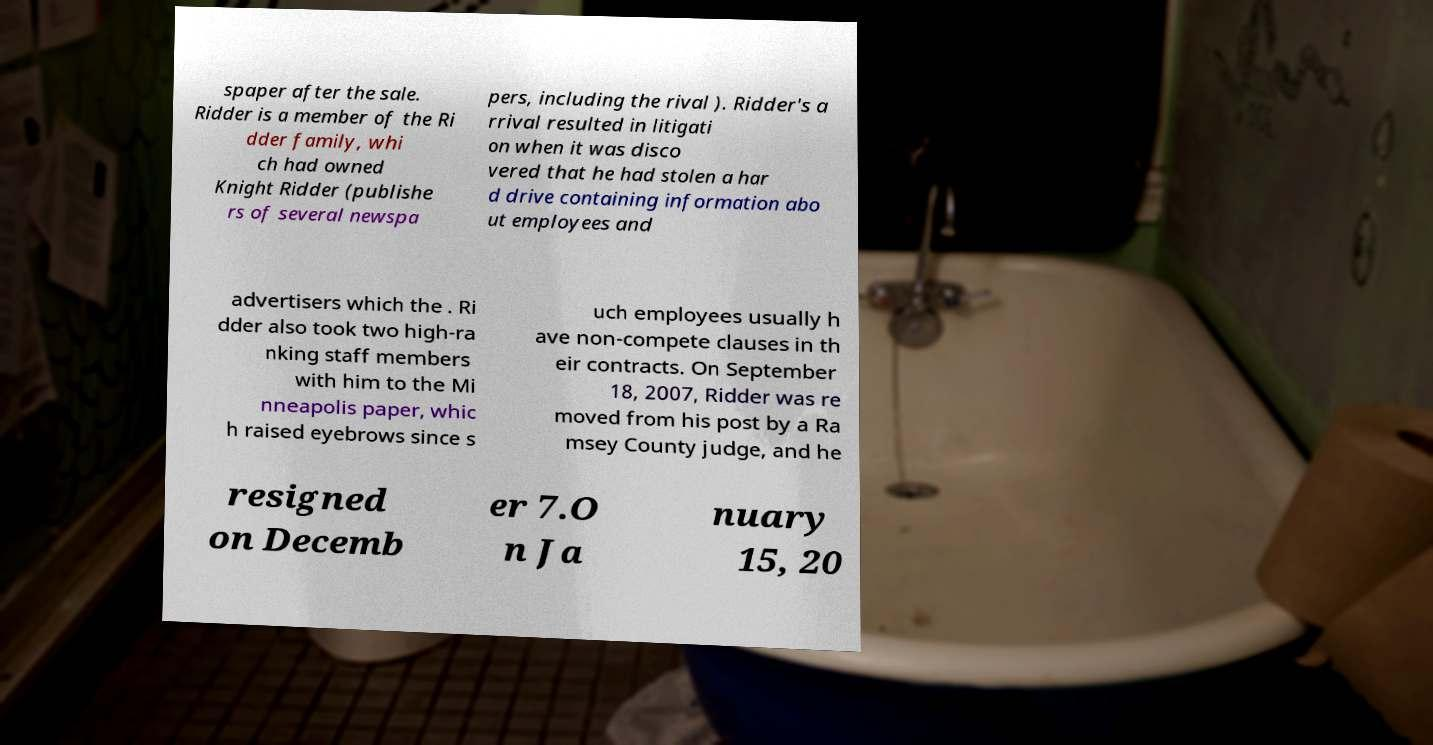Can you read and provide the text displayed in the image?This photo seems to have some interesting text. Can you extract and type it out for me? spaper after the sale. Ridder is a member of the Ri dder family, whi ch had owned Knight Ridder (publishe rs of several newspa pers, including the rival ). Ridder's a rrival resulted in litigati on when it was disco vered that he had stolen a har d drive containing information abo ut employees and advertisers which the . Ri dder also took two high-ra nking staff members with him to the Mi nneapolis paper, whic h raised eyebrows since s uch employees usually h ave non-compete clauses in th eir contracts. On September 18, 2007, Ridder was re moved from his post by a Ra msey County judge, and he resigned on Decemb er 7.O n Ja nuary 15, 20 